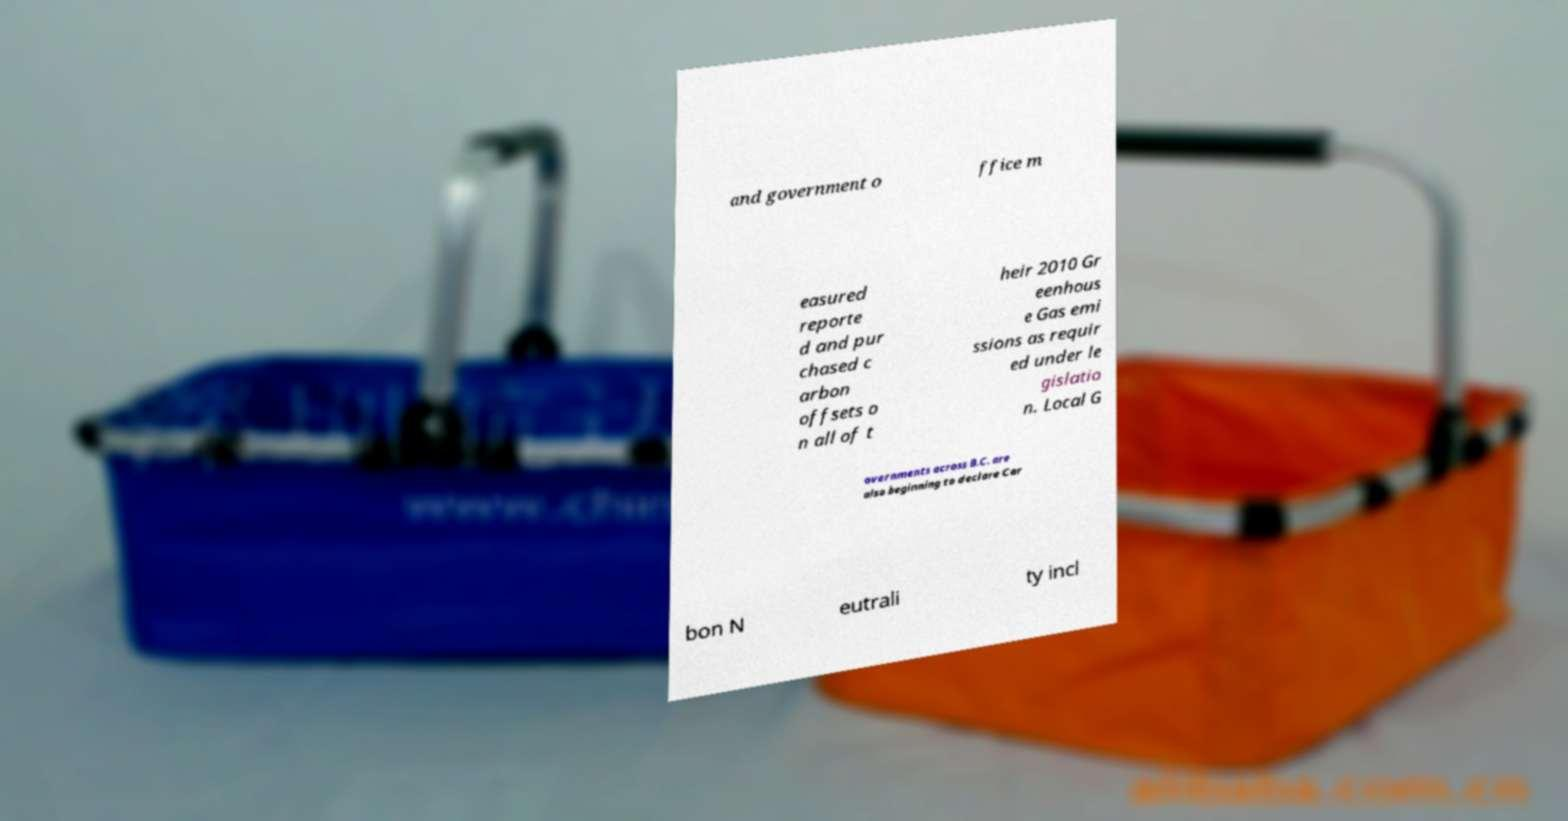Could you extract and type out the text from this image? and government o ffice m easured reporte d and pur chased c arbon offsets o n all of t heir 2010 Gr eenhous e Gas emi ssions as requir ed under le gislatio n. Local G overnments across B.C. are also beginning to declare Car bon N eutrali ty incl 